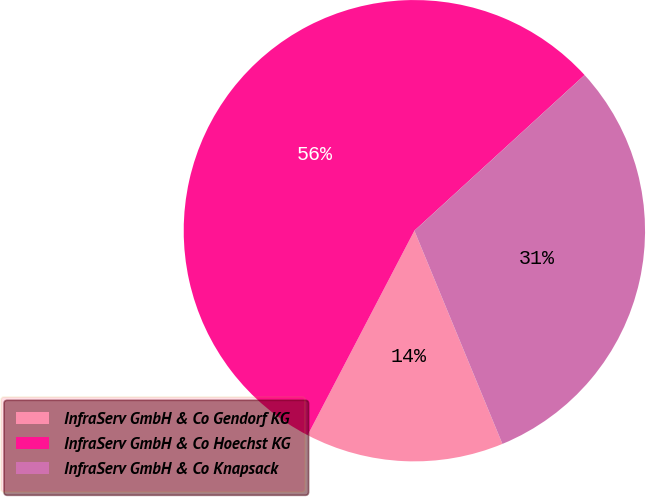Convert chart. <chart><loc_0><loc_0><loc_500><loc_500><pie_chart><fcel>InfraServ GmbH & Co Gendorf KG<fcel>InfraServ GmbH & Co Hoechst KG<fcel>InfraServ GmbH & Co Knapsack<nl><fcel>13.89%<fcel>55.56%<fcel>30.56%<nl></chart> 